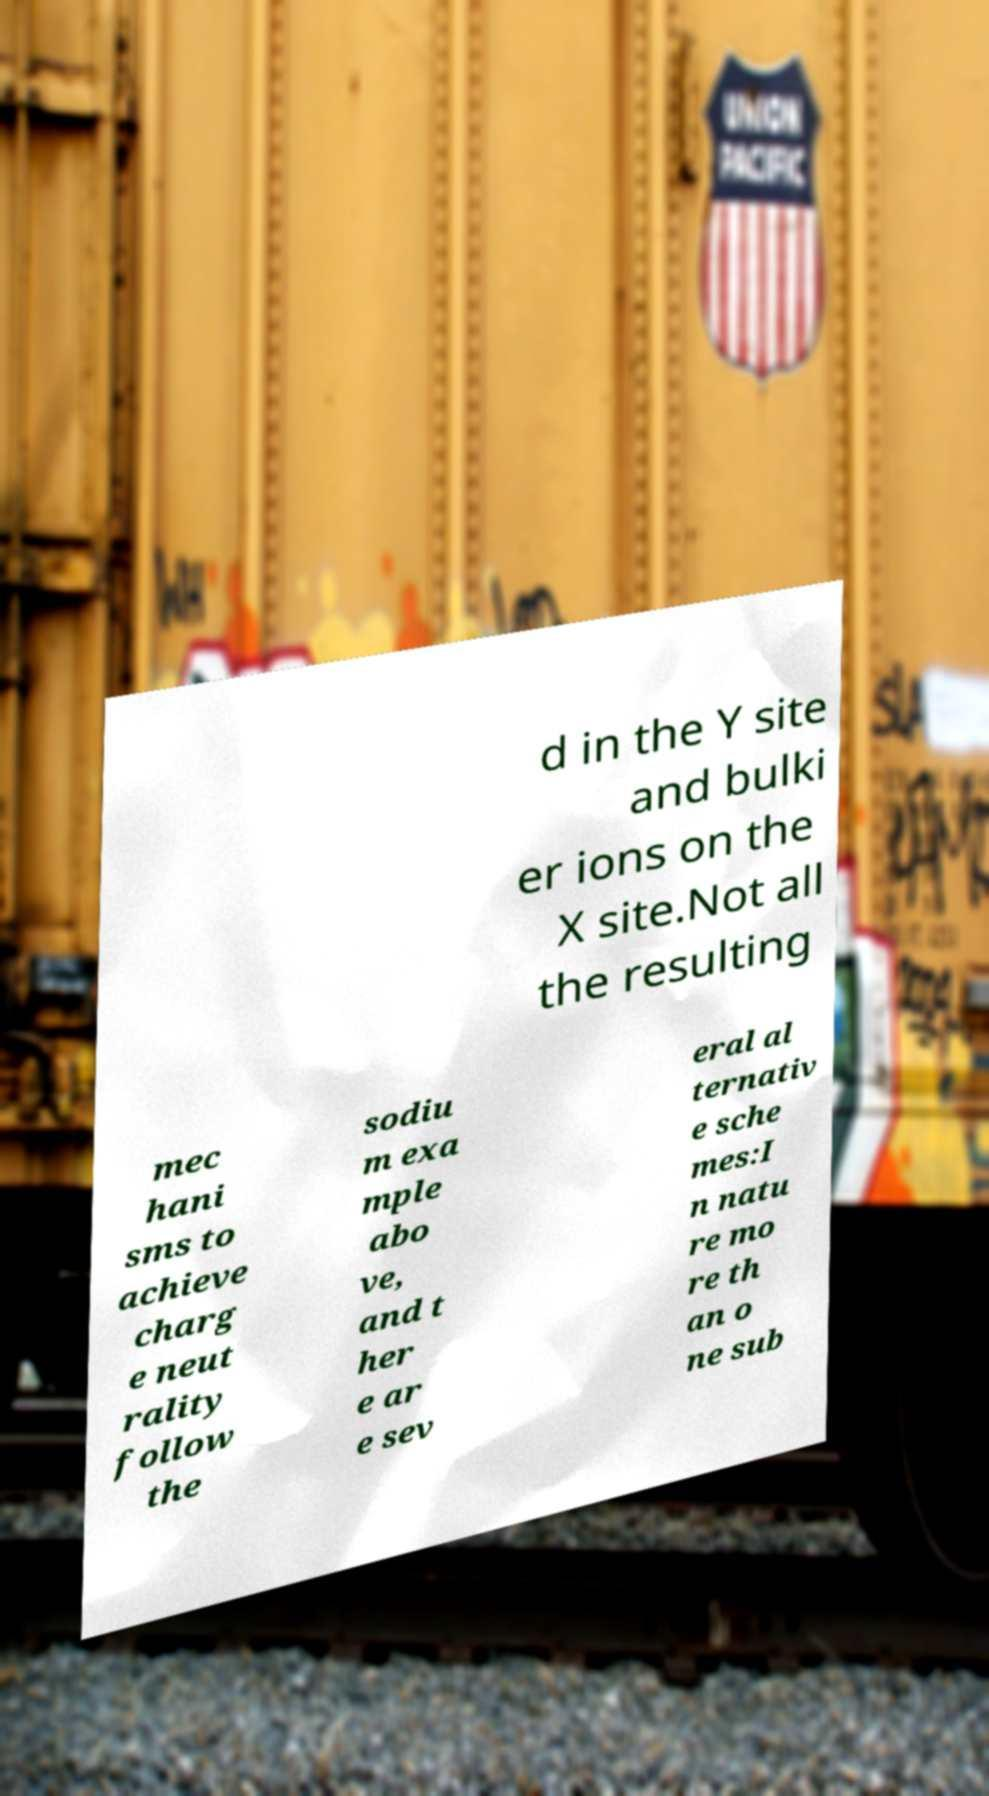What messages or text are displayed in this image? I need them in a readable, typed format. d in the Y site and bulki er ions on the X site.Not all the resulting mec hani sms to achieve charg e neut rality follow the sodiu m exa mple abo ve, and t her e ar e sev eral al ternativ e sche mes:I n natu re mo re th an o ne sub 